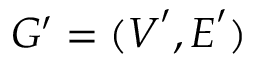Convert formula to latex. <formula><loc_0><loc_0><loc_500><loc_500>G ^ { \prime } = ( V ^ { \prime } , E ^ { \prime } )</formula> 